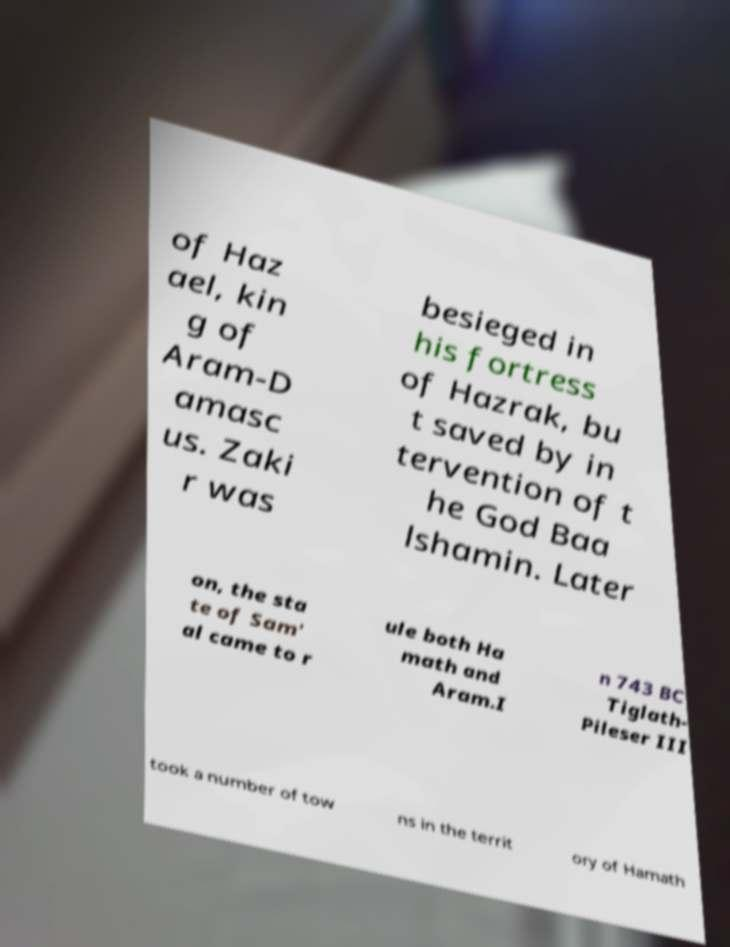Could you extract and type out the text from this image? of Haz ael, kin g of Aram-D amasc us. Zaki r was besieged in his fortress of Hazrak, bu t saved by in tervention of t he God Baa lshamin. Later on, the sta te of Sam' al came to r ule both Ha math and Aram.I n 743 BC Tiglath- Pileser III took a number of tow ns in the territ ory of Hamath 